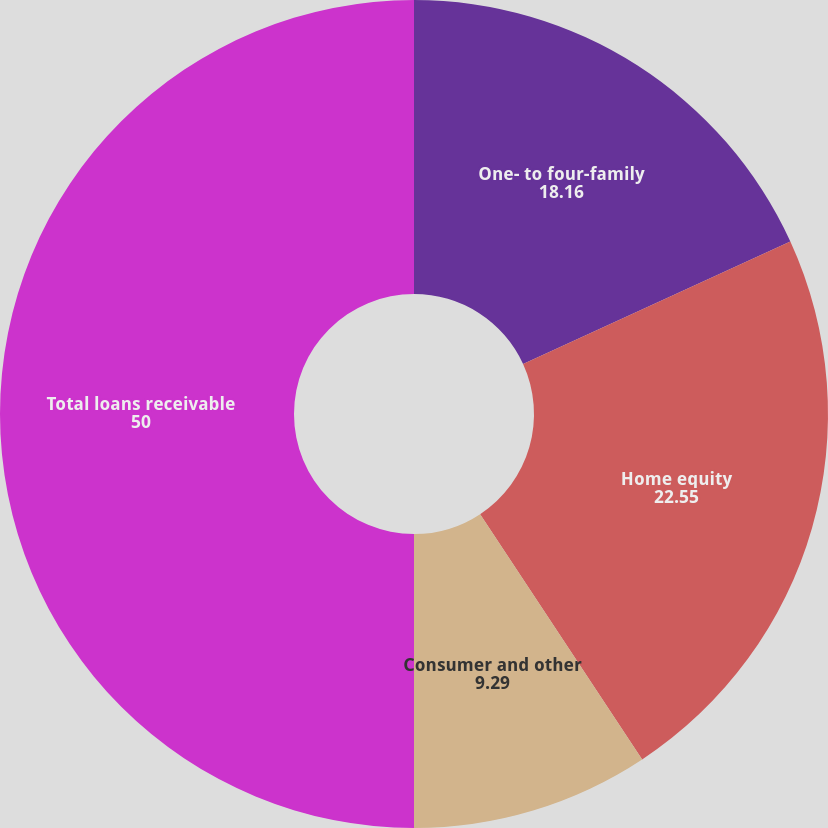Convert chart. <chart><loc_0><loc_0><loc_500><loc_500><pie_chart><fcel>One- to four-family<fcel>Home equity<fcel>Consumer and other<fcel>Total loans receivable<nl><fcel>18.16%<fcel>22.55%<fcel>9.29%<fcel>50.0%<nl></chart> 